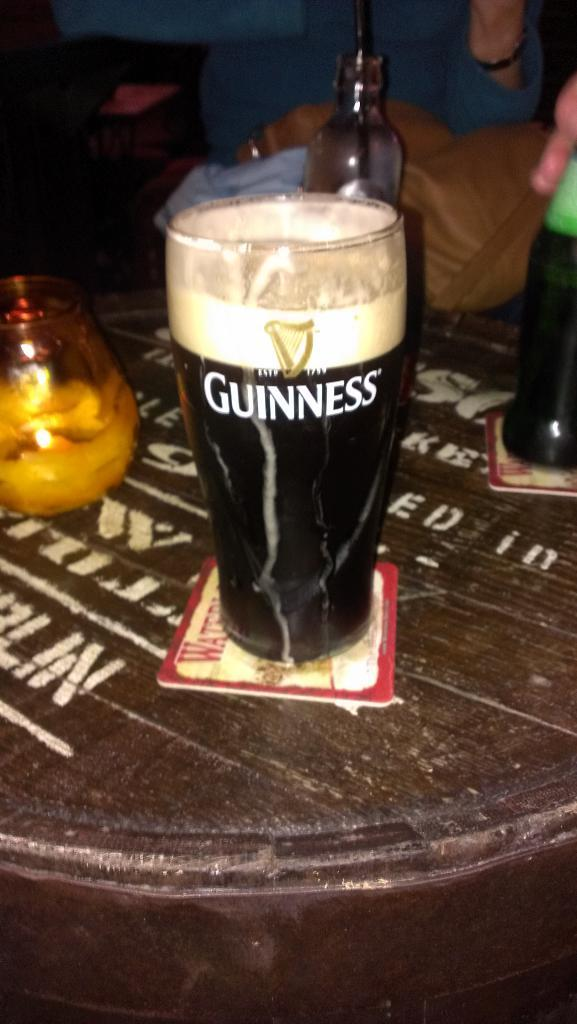<image>
Render a clear and concise summary of the photo. A glass of Guinness ale sits on a coaster on a table. 